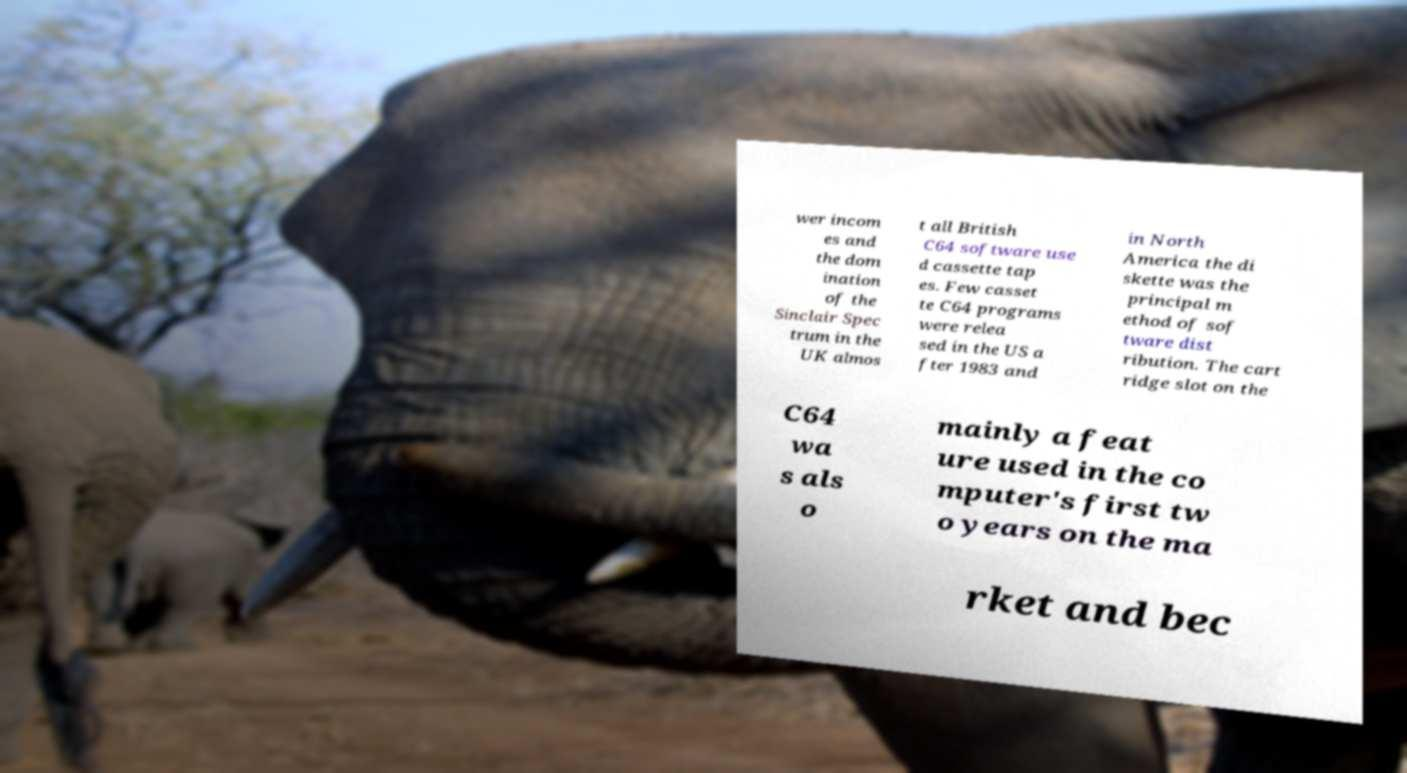Can you accurately transcribe the text from the provided image for me? wer incom es and the dom ination of the Sinclair Spec trum in the UK almos t all British C64 software use d cassette tap es. Few casset te C64 programs were relea sed in the US a fter 1983 and in North America the di skette was the principal m ethod of sof tware dist ribution. The cart ridge slot on the C64 wa s als o mainly a feat ure used in the co mputer's first tw o years on the ma rket and bec 